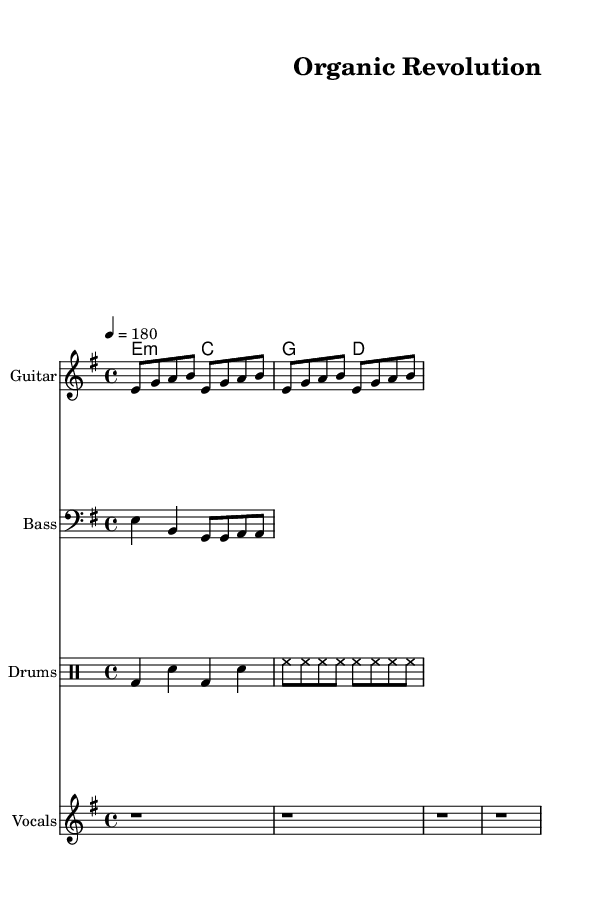What is the key signature of this music? The key signature is E minor, which corresponds to one sharp (F#). This can be identified by looking at the key signature at the beginning of the score.
Answer: E minor What is the time signature of this music? The time signature is 4/4, indicated at the beginning of the score. This means there are four beats in a measure, and the quarter note gets one beat.
Answer: 4/4 What is the tempo marking for this piece? The tempo marking is 180, which shows the beats per minute (BPM) for the piece. It is specified in metronome markings at the beginning of the score.
Answer: 180 What instruments are used in this arrangement? The arrangement includes Guitar, Bass, Drums, and Vocals. These are labeled at the beginning of each staff in the score.
Answer: Guitar, Bass, Drums, Vocals What phrase represents the verse in the lyrics? The verse lyrics start with "Con -- crete jun -- gles, pes -- ti -- cide haze". This can be seen directly under the staff for vocals in the vocal lyrics section.
Answer: Con -- crete jun -- gles, pes -- ti -- cide haze How many measures are in the chorus chords section? There are 2 measures indicated in the chorus chords section, as shown by the two sets of chord symbols. Each chord symbol represents one measure.
Answer: 2 What is the main theme of this composition reflected in its lyrics? The main theme focuses on promoting organic gardening methods and critiquing industrial agriculture, as seen from phrases emphasizing "Grow organic" and "eco-revolution" in the chorus. This thematic content is woven throughout the lyrics.
Answer: Eco-revolution 